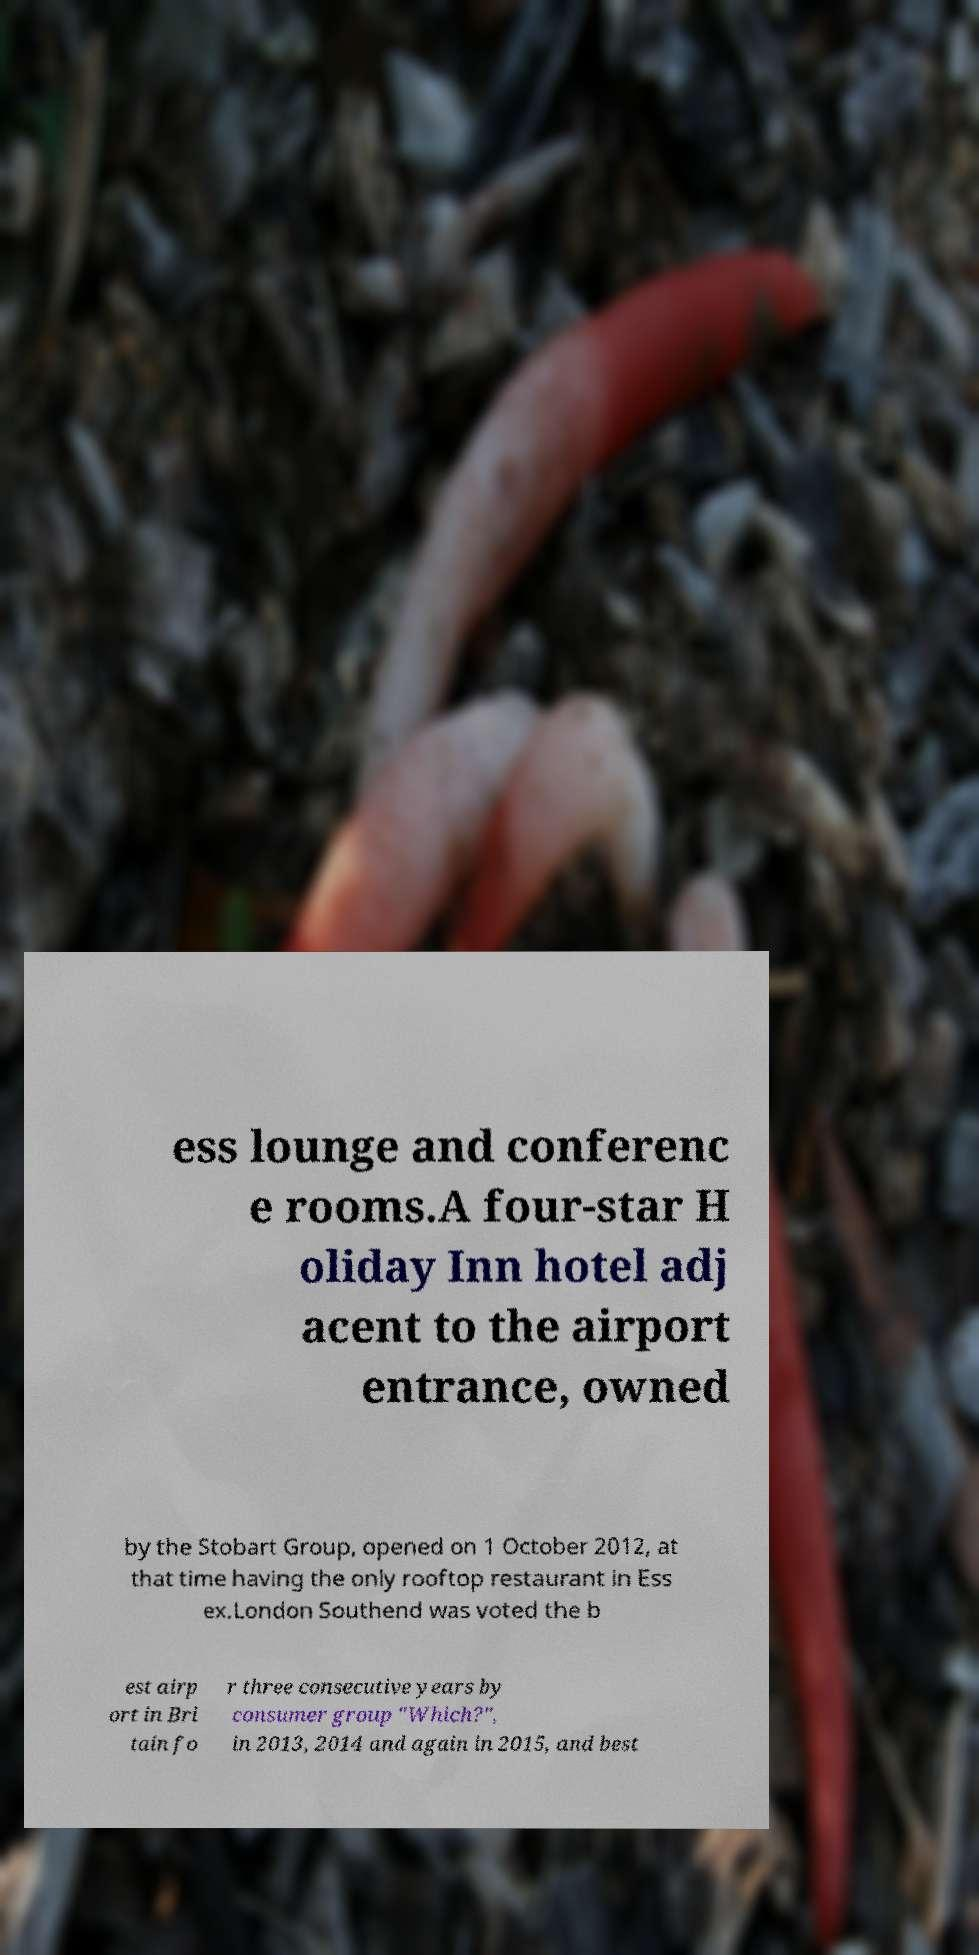Could you extract and type out the text from this image? ess lounge and conferenc e rooms.A four-star H oliday Inn hotel adj acent to the airport entrance, owned by the Stobart Group, opened on 1 October 2012, at that time having the only rooftop restaurant in Ess ex.London Southend was voted the b est airp ort in Bri tain fo r three consecutive years by consumer group "Which?", in 2013, 2014 and again in 2015, and best 